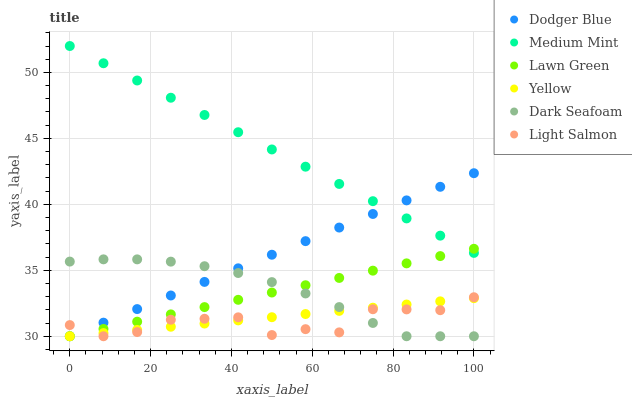Does Light Salmon have the minimum area under the curve?
Answer yes or no. Yes. Does Medium Mint have the maximum area under the curve?
Answer yes or no. Yes. Does Lawn Green have the minimum area under the curve?
Answer yes or no. No. Does Lawn Green have the maximum area under the curve?
Answer yes or no. No. Is Yellow the smoothest?
Answer yes or no. Yes. Is Light Salmon the roughest?
Answer yes or no. Yes. Is Lawn Green the smoothest?
Answer yes or no. No. Is Lawn Green the roughest?
Answer yes or no. No. Does Lawn Green have the lowest value?
Answer yes or no. Yes. Does Medium Mint have the highest value?
Answer yes or no. Yes. Does Lawn Green have the highest value?
Answer yes or no. No. Is Light Salmon less than Medium Mint?
Answer yes or no. Yes. Is Medium Mint greater than Yellow?
Answer yes or no. Yes. Does Lawn Green intersect Dark Seafoam?
Answer yes or no. Yes. Is Lawn Green less than Dark Seafoam?
Answer yes or no. No. Is Lawn Green greater than Dark Seafoam?
Answer yes or no. No. Does Light Salmon intersect Medium Mint?
Answer yes or no. No. 